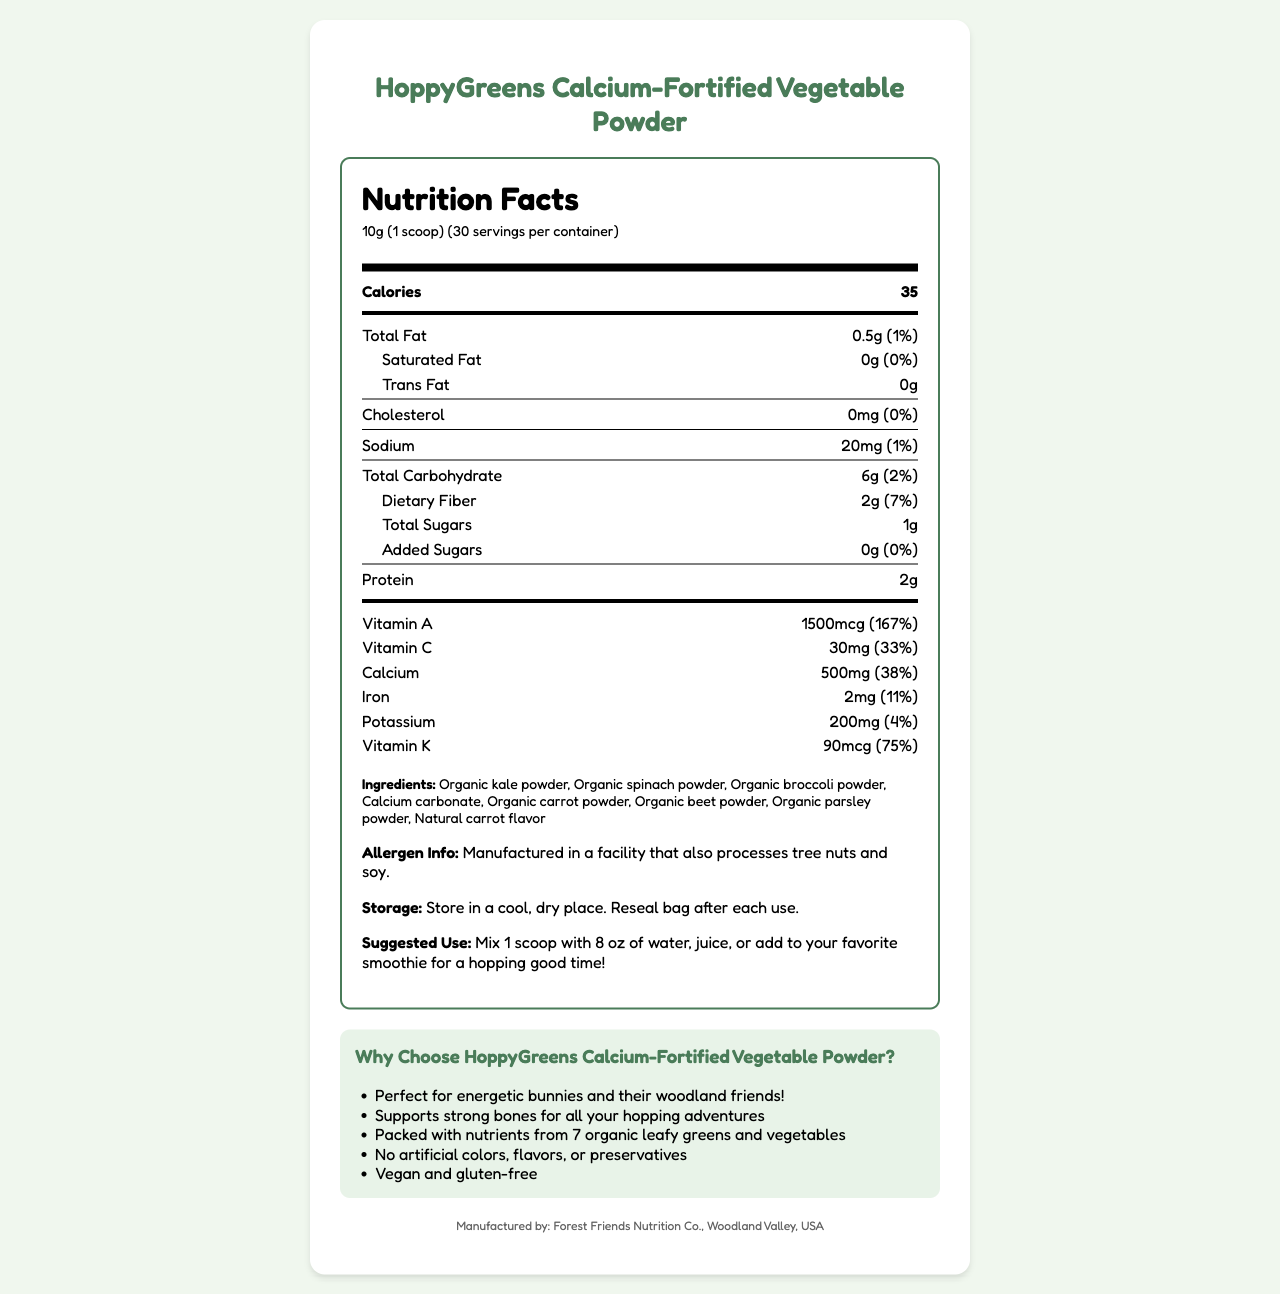what is the serving size? The serving size is specified in the "servingSize" section as "10g (1 scoop)".
Answer: 10g (1 scoop) how many calories are in one serving? The number of calories per serving is listed as "35" in the "caloriesPerServing" section.
Answer: 35 what is the total fat content per serving? The total fat content per serving is given as "0.5g" in the "totalFat" section.
Answer: 0.5g which ingredient is used for calcium fortification? A. Organic kale powder B. Organic spinach powder C. Calcium carbonate D. Natural carrot flavor The list of ingredients includes "Calcium carbonate," which is used for calcium fortification.
Answer: C. Calcium carbonate how should I store the HoppyGreens Calcium-Fortified Vegetable Powder? The storage instructions indicate to store the powder in a cool, dry place and to reseal the bag after each use.
Answer: Store in a cool, dry place. Reseal bag after each use. does the product contain added sugars? The "addedSugars" section states "0g," indicating that there are no added sugars.
Answer: No how many servings are there per container? The document mentions that there are "30" servings per container.
Answer: 30 which vitamin has the highest daily value percentage? The "vitaminA" section has a daily value percentage of "167%", which is the highest among the listed vitamins and minerals.
Answer: Vitamin A how much dietary fiber is in one serving? The dietary fiber content per serving is listed as "2g" in the "dietaryFiber" section.
Answer: 2g is the product gluten-free? The product claims to be "gluten-free" according to the marketing claims.
Answer: Yes how much calcium does one serving provide? The calcium content is given as "500mg" per serving in the "calcium" section.
Answer: 500mg what does the product's marketing claim about its intended users? A. Professional athletes B. Energetic bunnies and their woodland friends C. Children under 5 years D. Elderly people One of the marketing claims states that it's "Perfect for energetic bunnies and their woodland friends!"
Answer: B. Energetic bunnies and their woodland friends does the product contain any cholesterol? The "cholesterol" section states "0mg," indicating that there is no cholesterol in the product.
Answer: No how much vitamin C does one serving contain? The vitamin C content per serving is given as "30mg" in the "vitaminC" section.
Answer: 30mg what is the total carbohydrate content per serving? The total carbohydrate amount per serving is listed as "6g" in the "totalCarbohydrate" section.
Answer: 6g how should I use this vegetable powder? The suggested use instructions recommend mixing 1 scoop with 8 oz of water, juice, or adding it to a smoothie.
Answer: Mix 1 scoop with 8 oz of water, juice, or add to your favorite smoothie for a hopping good time! summarize the key information provided in the HoppyGreens Calcium-Fortified Vegetable Powder document. The document includes details about serving size, nutrient content, ingredients, allergen information, storage, suggested use, and marketing claims, all of which highlight the product’s nutritional benefits, natural ingredients, and targeted user base.
Answer: The HoppyGreens Calcium-Fortified Vegetable Powder is a nutritional supplement designed especially for energetic creatures like bunnies and their woodland friends. Each 10g serving provides 35 calories and includes 500mg of calcium for strong bones. The product contains a blend of organic vegetable powders and natural carrot flavor. It's manufactured without artificial colors, flavors, or preservatives and is both vegan and gluten-free. The suggested use is to mix one scoop with 8 oz of water, juice, or a smoothie. Storage instructions advise keeping it in a cool, dry place. what company manufactures this product? Located at the bottom of the document, it states, "Manufactured by: Forest Friends Nutrition Co., Woodland Valley, USA".
Answer: Forest Friends Nutrition Co., Woodland Valley, USA are there any artificial colors in the product? The marketing claims clearly state "No artificial colors," indicating the product does not contain artificial colors.
Answer: No what are the allergens present in the product? The allergen info section mentions that the product is manufactured in a facility that processes tree nuts and soy.
Answer: The product itself doesn't contain specific allergens, but it is manufactured in a facility that also processes tree nuts and soy. how many grams of protein are in one serving? The protein content per serving is listed as "2g" in the "protein" section.
Answer: 2g how much potassium is in one serving of the HoppyGreens powder? The potassium content per serving is listed as "200mg" in the "potassium" section.
Answer: 200mg 